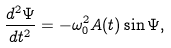Convert formula to latex. <formula><loc_0><loc_0><loc_500><loc_500>\frac { d ^ { 2 } \Psi } { d t ^ { 2 } } = - \omega _ { 0 } ^ { 2 } A ( t ) \sin \Psi ,</formula> 